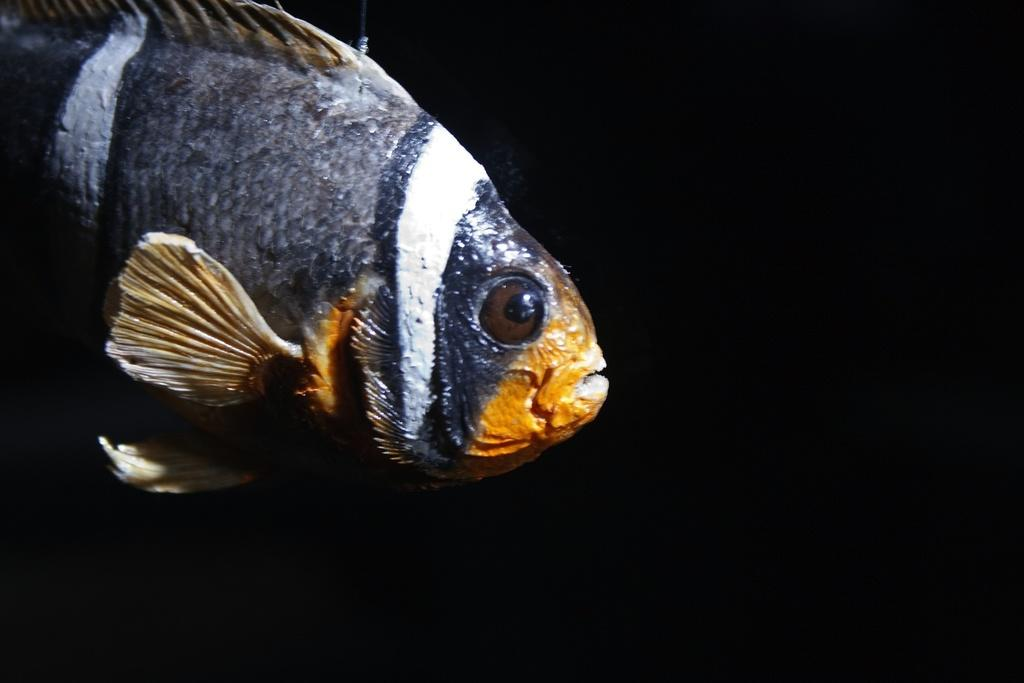What is the main subject of the picture? The main subject of the picture is a fish. What can be observed about the fish's mouth? The fish has a yellow color mouth. What body parts does the fish have for swimming? The fish has fins. What type of covering does the fish have on its body? The fish has scales. What is the color scheme of the background in the image? The backdrop of the image is dark. Can you tell me how many twigs are wrapped around the fish's body in the image? There are no twigs present in the image; it features a fish with fins and scales. What type of scarf is the fish wearing in the image? There is no scarf present in the image; the fish has scales covering its body. 